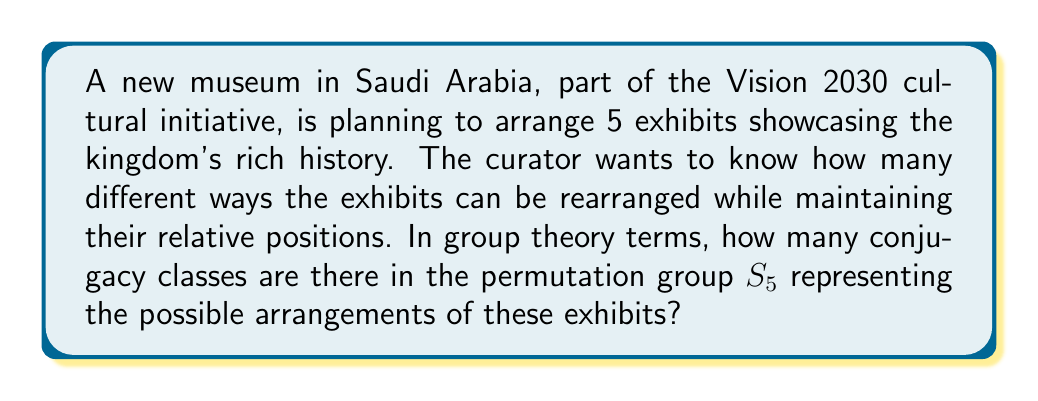What is the answer to this math problem? To solve this problem, we need to understand the concept of conjugacy classes in the symmetric group $S_5$. 

1) In $S_5$, conjugacy classes correspond to cycle types. Two permutations are in the same conjugacy class if and only if they have the same cycle structure.

2) The possible cycle types in $S_5$ are:
   - $(1)(1)(1)(1)(1)$ : identity permutation
   - $(2)(1)(1)(1)$ : transpositions
   - $(2)(2)(1)$ : product of two disjoint transpositions
   - $(3)(1)(1)$ : 3-cycles
   - $(3)(2)$ : product of a 3-cycle and a transposition
   - $(4)(1)$ : 4-cycles
   - $(5)$ : 5-cycles

3) Each of these cycle types represents a unique conjugacy class in $S_5$.

4) Therefore, we simply need to count the number of different cycle types.

5) From the list above, we can see that there are 7 different cycle types.

Thus, there are 7 conjugacy classes in $S_5$, representing 7 fundamentally different ways to rearrange the 5 exhibits in the Saudi museum.
Answer: The number of conjugacy classes in $S_5$ is 7. 